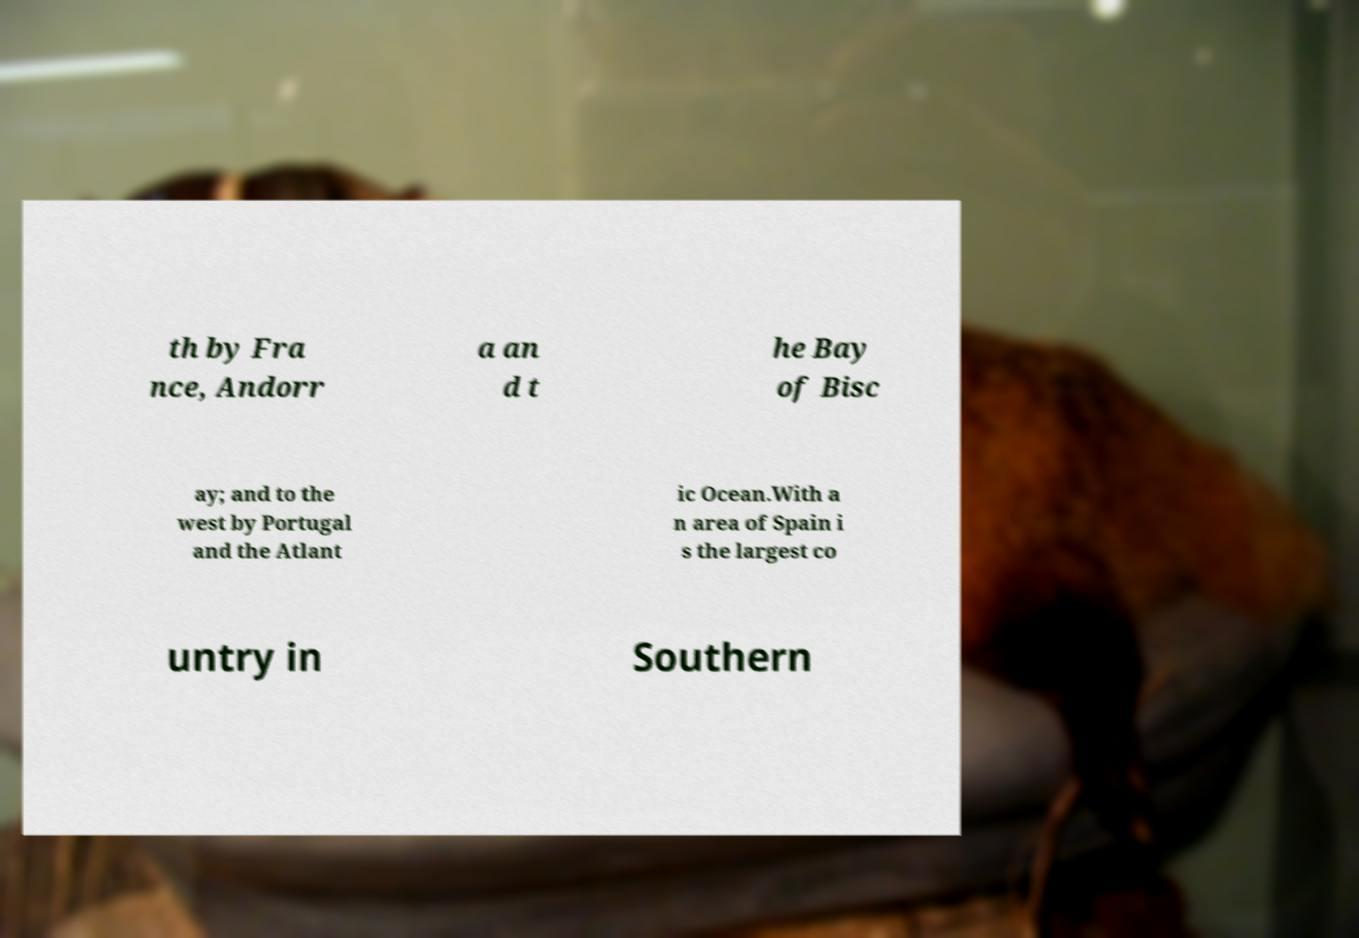There's text embedded in this image that I need extracted. Can you transcribe it verbatim? th by Fra nce, Andorr a an d t he Bay of Bisc ay; and to the west by Portugal and the Atlant ic Ocean.With a n area of Spain i s the largest co untry in Southern 